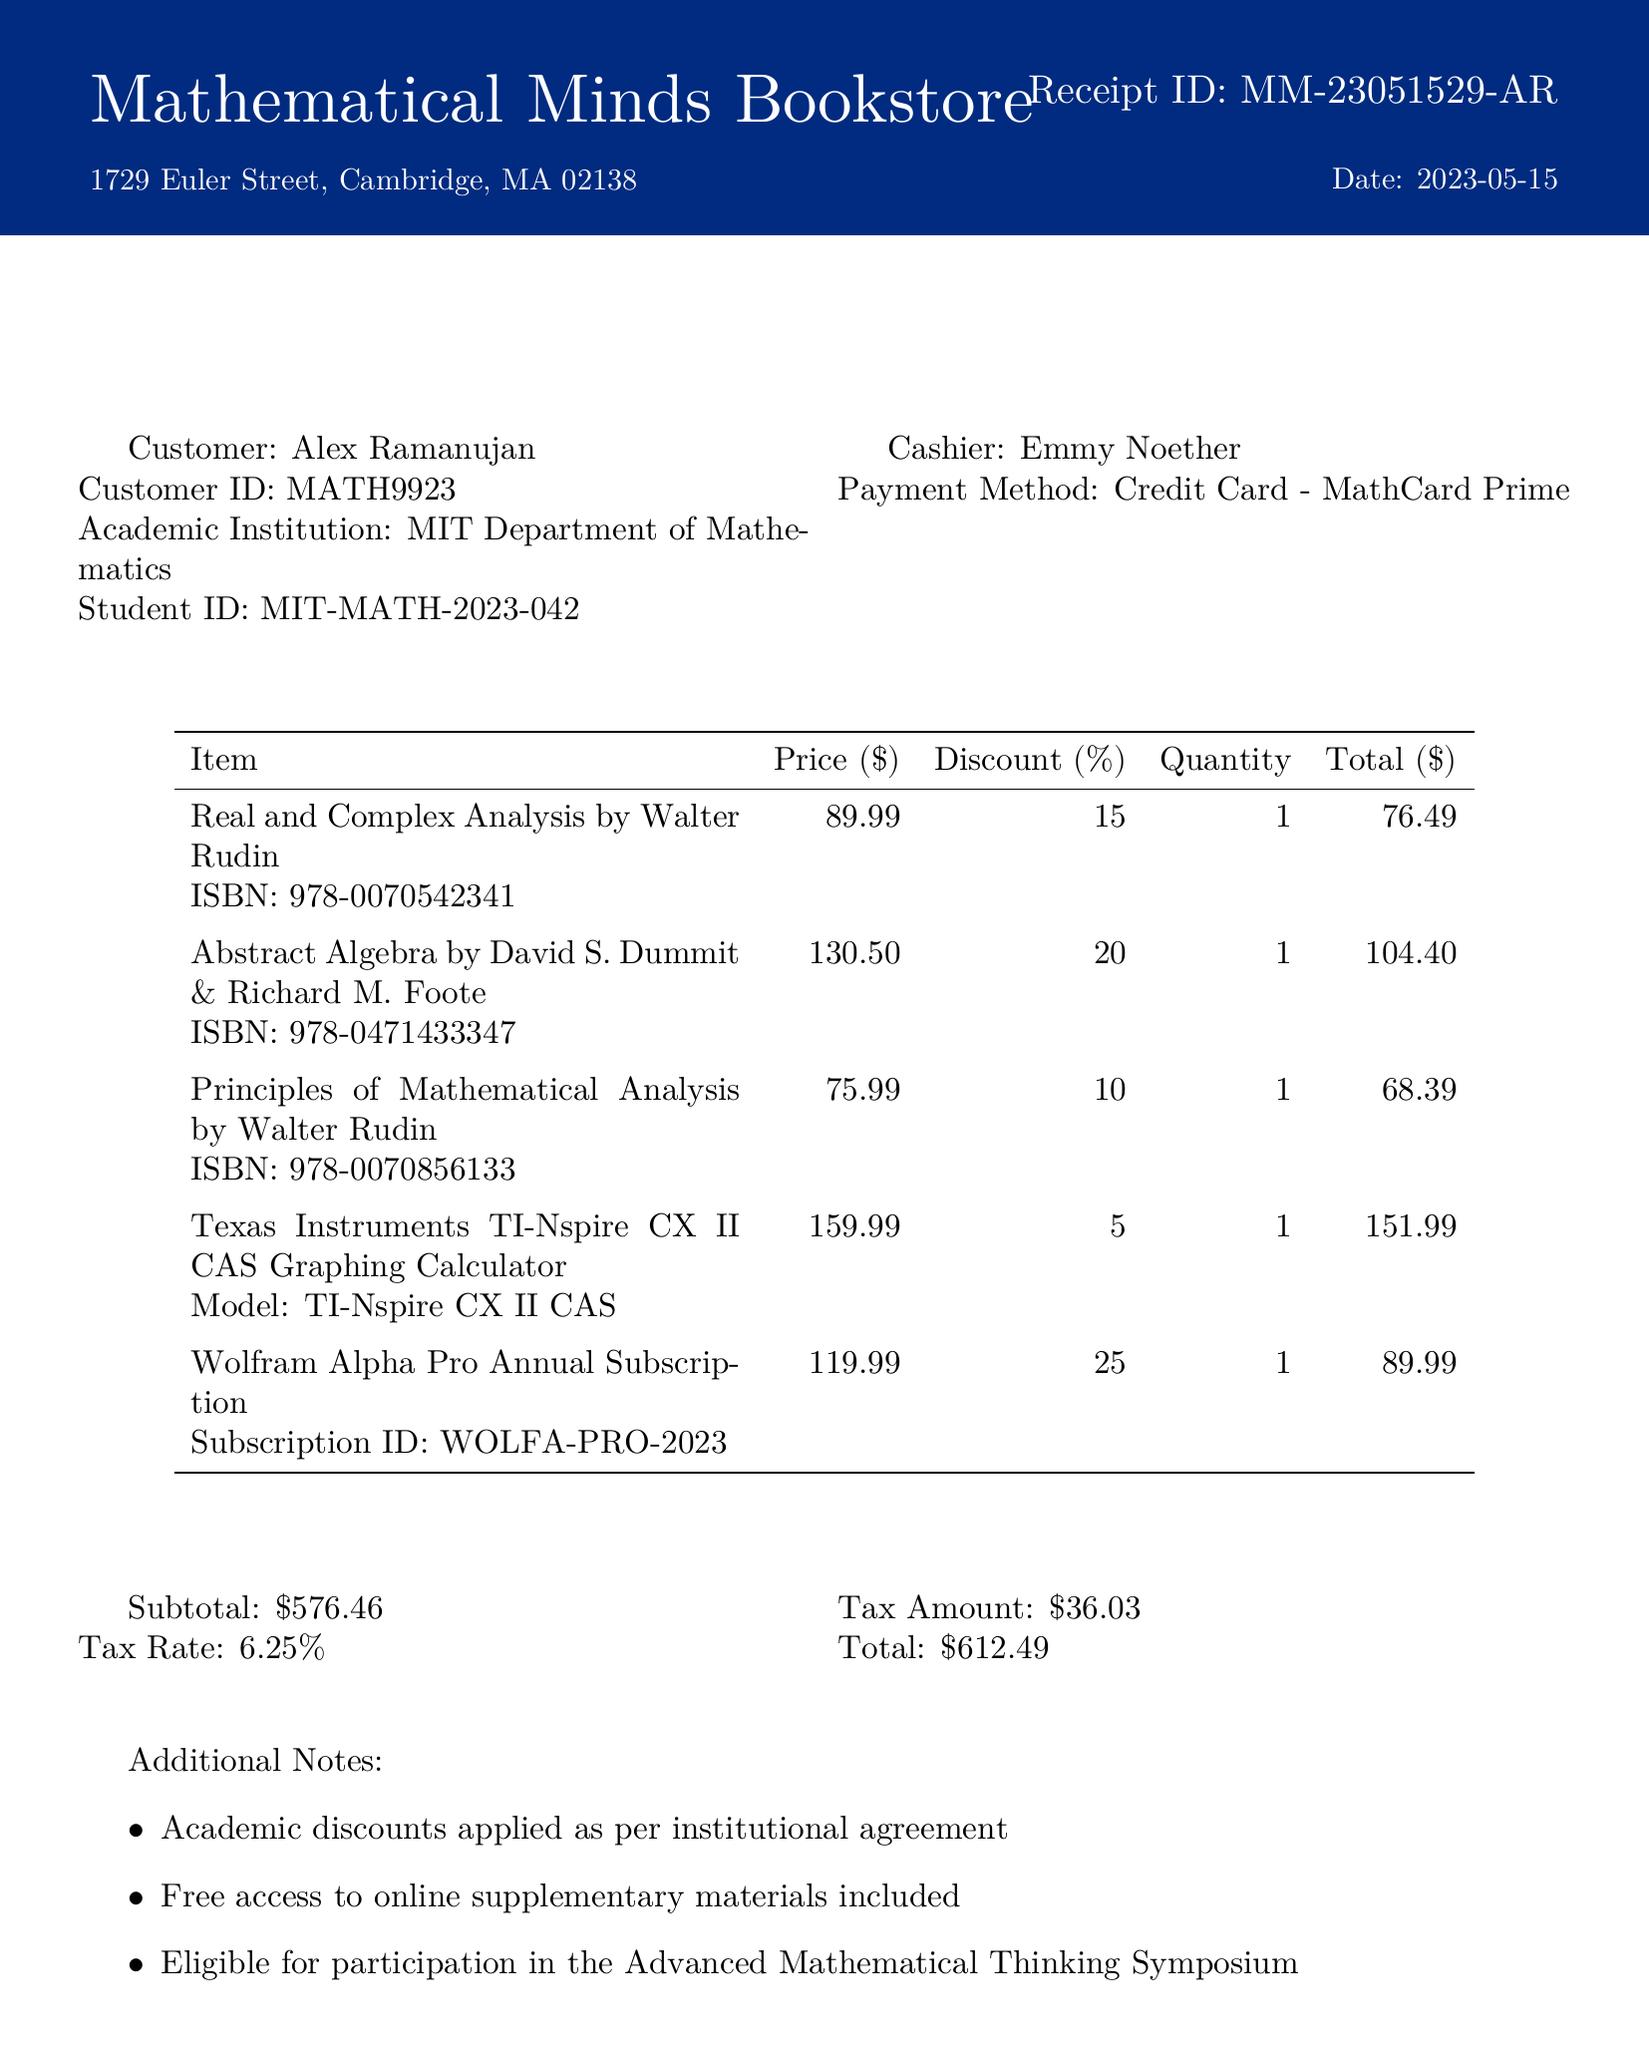What is the name of the bookstore? The name of the bookstore is stated at the top of the receipt.
Answer: Mathematical Minds Bookstore Who issued the receipt? The cashier's name is mentioned in the document indicating who issued it.
Answer: Emmy Noether What is the date of the transaction? The date is explicitly provided in the document.
Answer: 2023-05-15 How many books were purchased? The document lists five items, all of which are books or related to academics.
Answer: 5 What is the total amount paid? The total amount is summarized at the end of the receipt.
Answer: 612.49 What discount was applied to the Wolfram Alpha Pro Annual Subscription? The discount for this specific item is indicated in the breakdown.
Answer: 25 What is the quantity of the Texas Instruments TI-Nspire CX II CAS Graphing Calculator purchased? The quantity for this item is specified in the document.
Answer: 1 Which academic institution is associated with the customer? The academic institution is mentioned as part of the customer's information.
Answer: MIT Department of Mathematics What is the subtotal before tax? The subtotal is provided in the financial summary of the document.
Answer: 576.46 